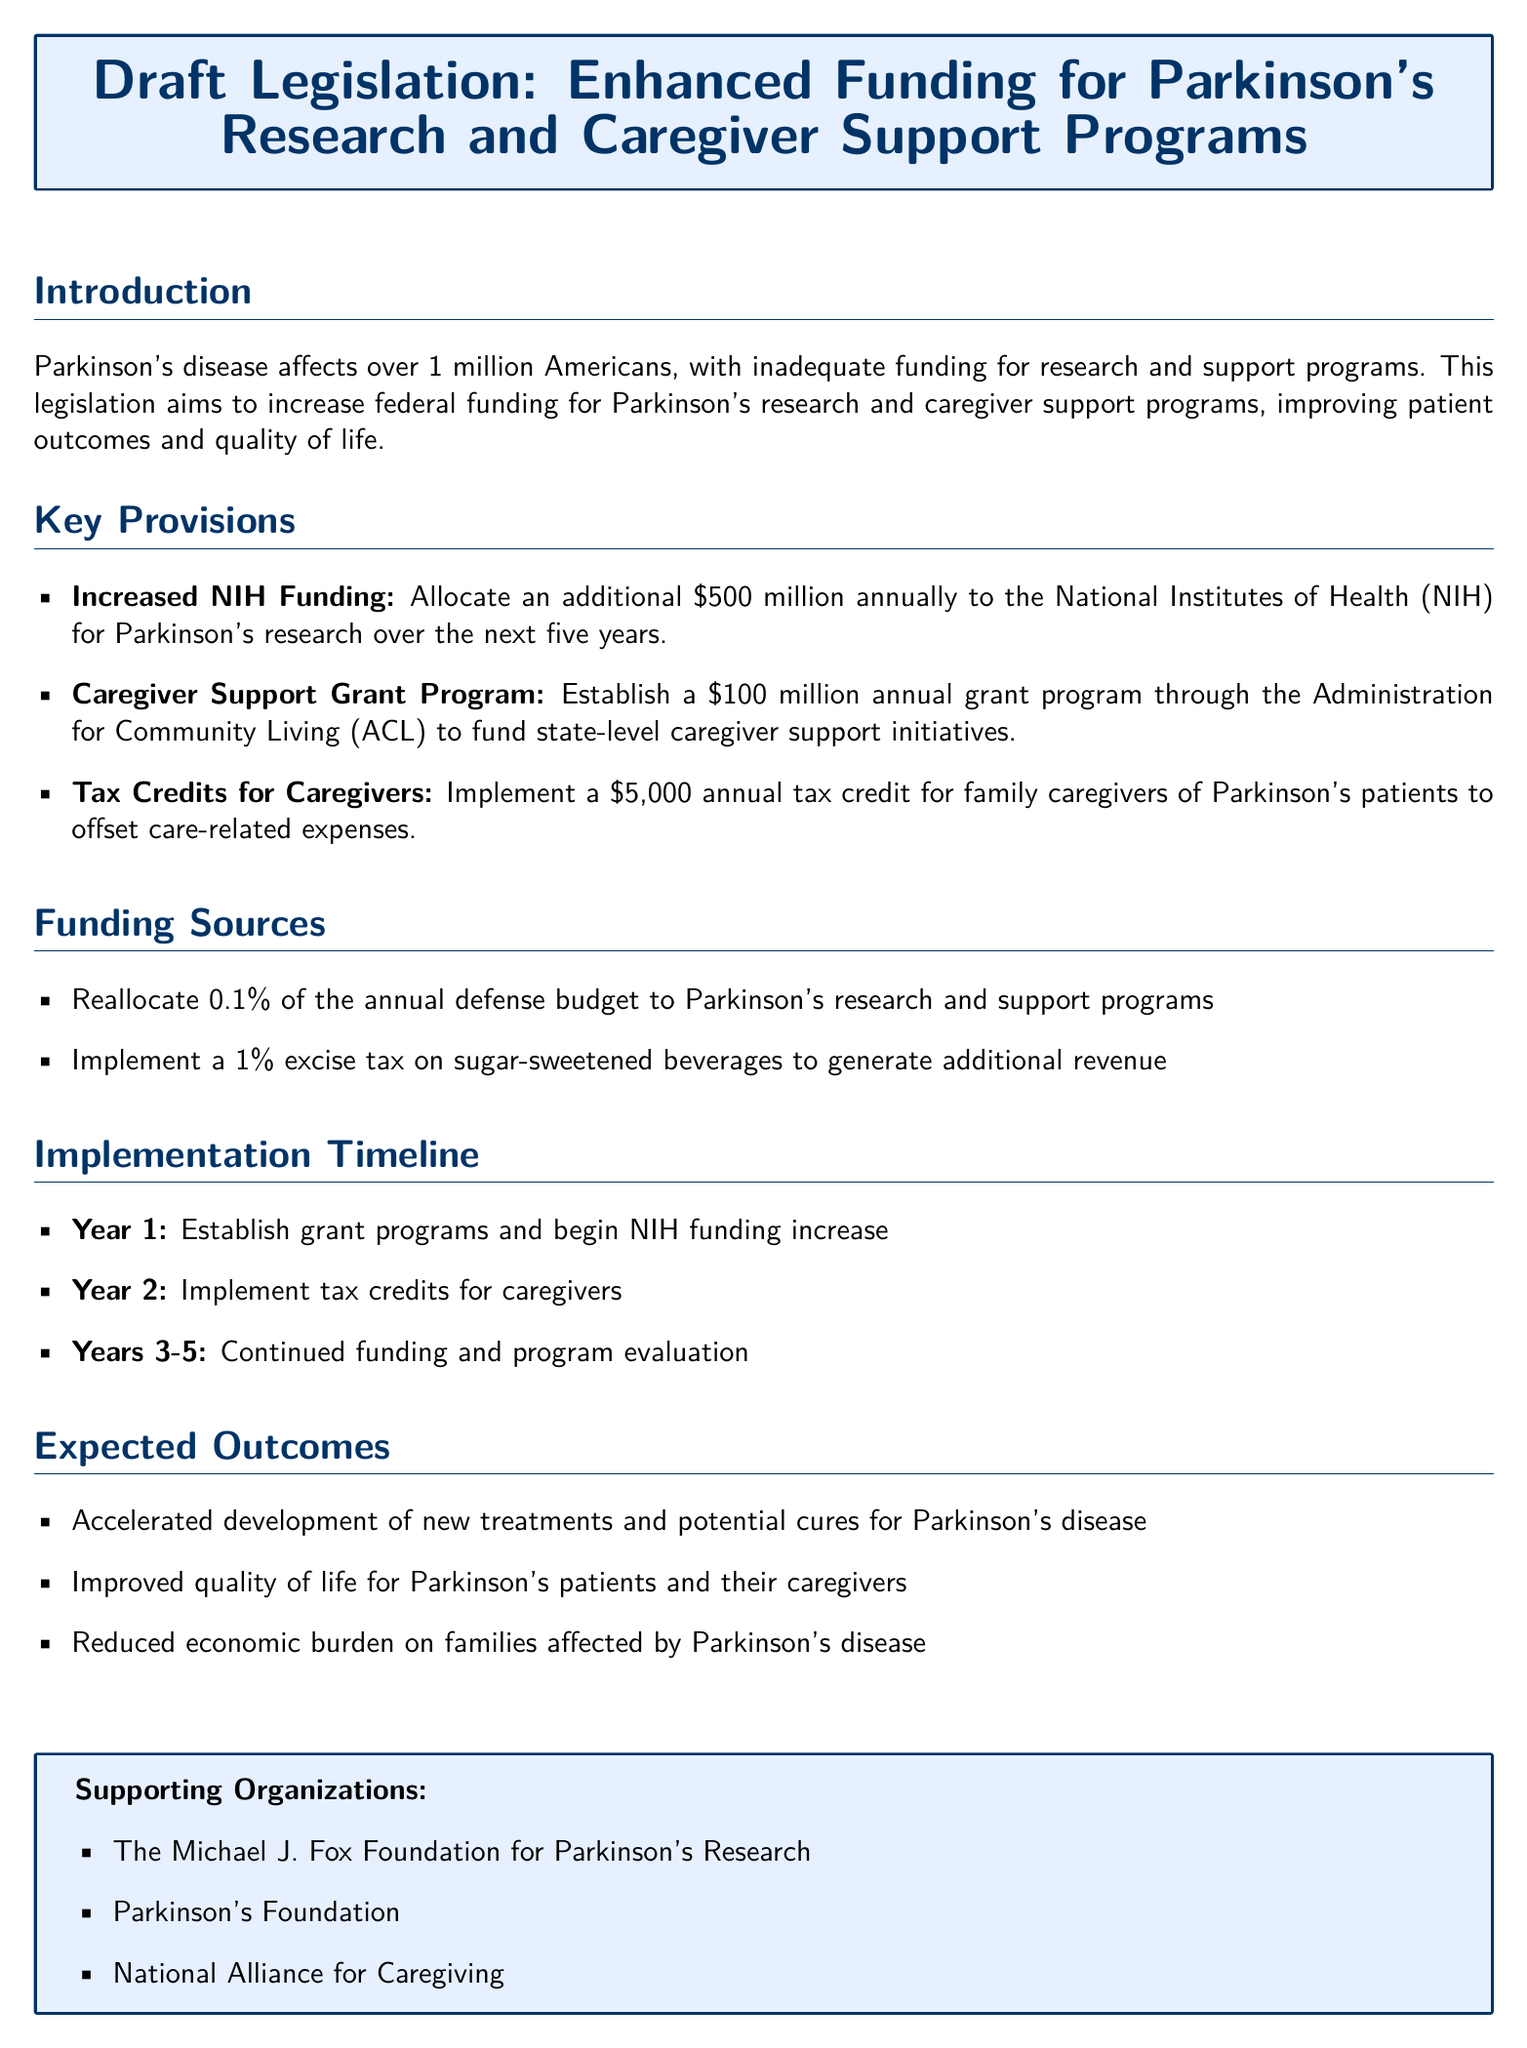What is the total additional funding allocated to the NIH for Parkinson's research? The document states that an additional $500 million annually will be allocated to the NIH for Parkinson's research.
Answer: $500 million What is the amount proposed for the caregiver support grant program? The draft legislation mentions a $100 million annual grant program for caregiver support initiatives.
Answer: $100 million What annual tax credit is proposed for family caregivers? The document indicates a $5,000 annual tax credit for family caregivers of Parkinson's patients.
Answer: $5,000 What percentage of the annual defense budget is proposed to be reallocated? The draft includes the reallocation of 0.1% of the annual defense budget to Parkinson's programs.
Answer: 0.1% Which organization is mentioned as supporting the legislation? The Michael J. Fox Foundation for Parkinson's Research is listed as a supporting organization.
Answer: The Michael J. Fox Foundation for Parkinson's Research What year is the caregiver tax credit scheduled to be implemented? According to the timeline, the caregiver tax credit will be implemented in Year 2.
Answer: Year 2 What is expected to be an outcome of this legislation? The expected outcomes listed include accelerated development of new treatments for Parkinson's disease.
Answer: Accelerated development of new treatments What is the main goal of this draft legislation? The legislation aims to increase funding for Parkinson's research and caregiver support programs.
Answer: Increase funding for Parkinson's research and caregiver support programs How many years is the NIH funding increase planned to occur over? The document specifies that the NIH funding increase is planned over the next five years.
Answer: Five years 